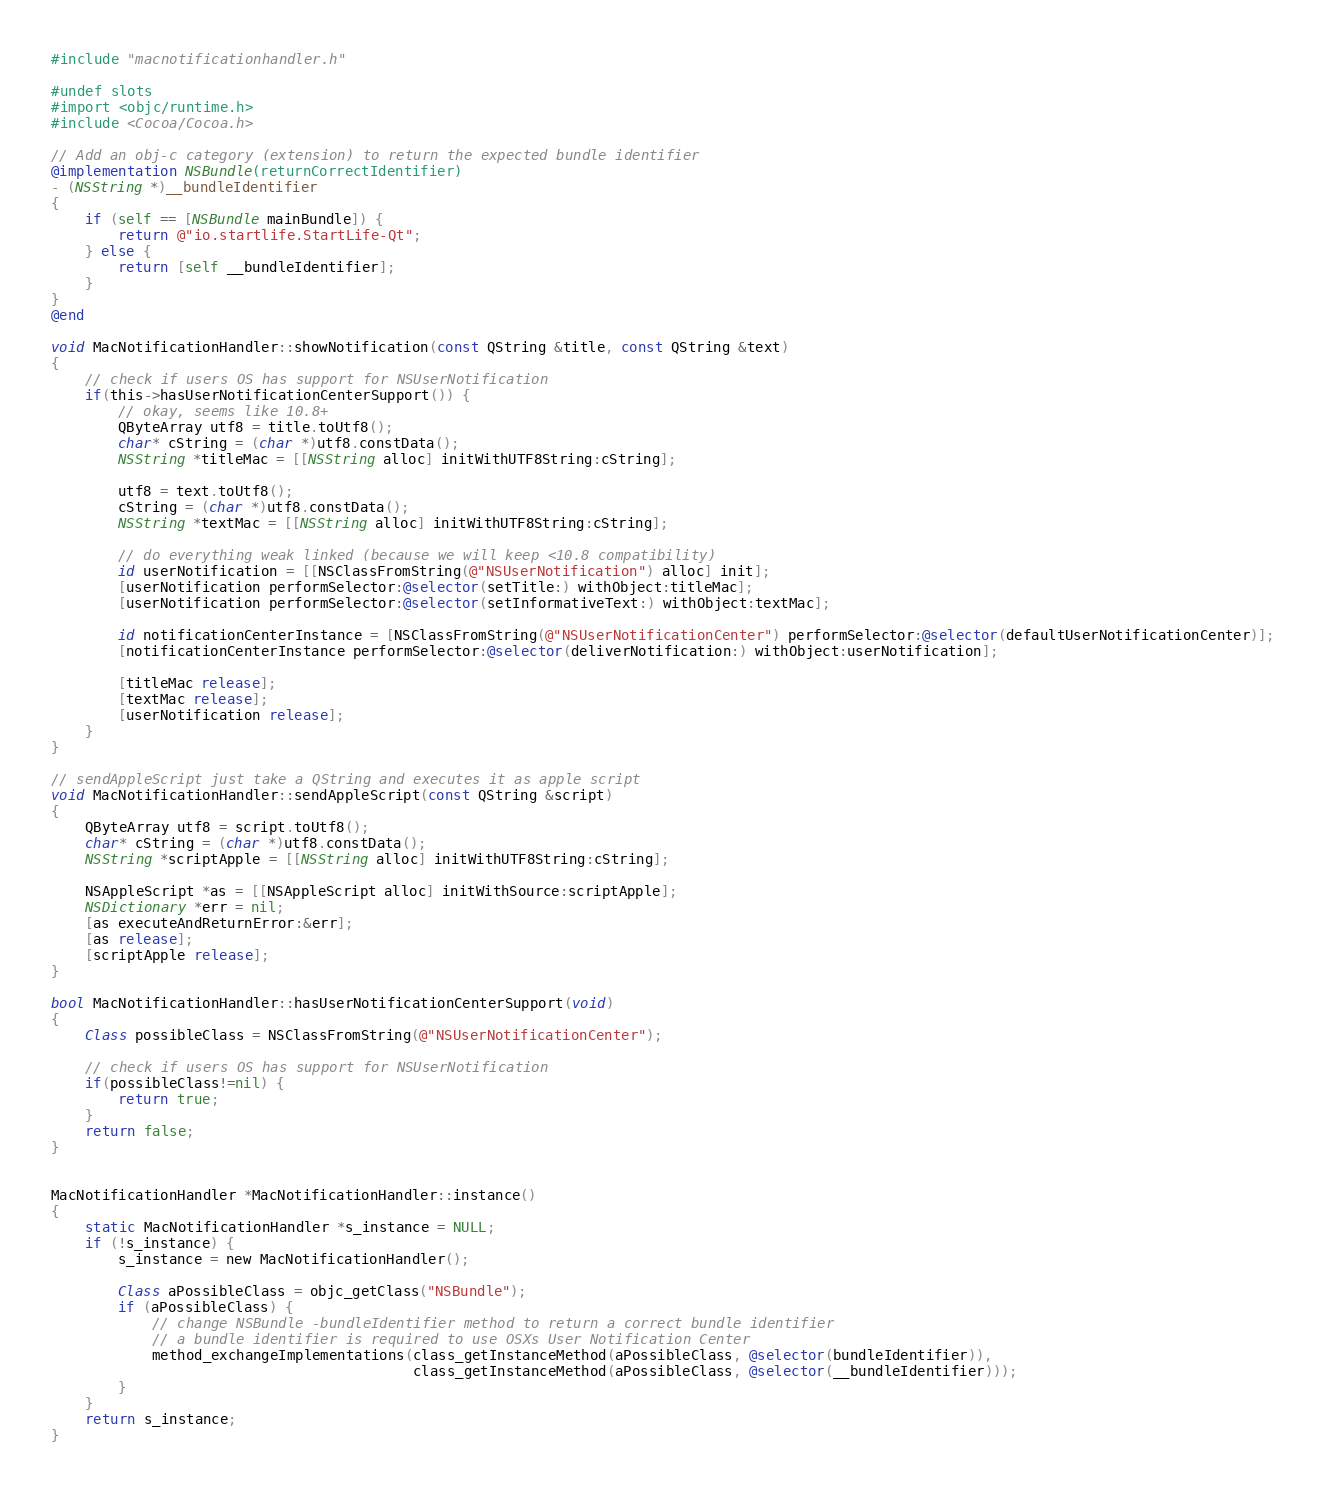Convert code to text. <code><loc_0><loc_0><loc_500><loc_500><_ObjectiveC_>
#include "macnotificationhandler.h"

#undef slots
#import <objc/runtime.h>
#include <Cocoa/Cocoa.h>

// Add an obj-c category (extension) to return the expected bundle identifier
@implementation NSBundle(returnCorrectIdentifier)
- (NSString *)__bundleIdentifier
{
    if (self == [NSBundle mainBundle]) {
        return @"io.startlife.StartLife-Qt";
    } else {
        return [self __bundleIdentifier];
    }
}
@end

void MacNotificationHandler::showNotification(const QString &title, const QString &text)
{
    // check if users OS has support for NSUserNotification
    if(this->hasUserNotificationCenterSupport()) {
        // okay, seems like 10.8+
        QByteArray utf8 = title.toUtf8();
        char* cString = (char *)utf8.constData();
        NSString *titleMac = [[NSString alloc] initWithUTF8String:cString];

        utf8 = text.toUtf8();
        cString = (char *)utf8.constData();
        NSString *textMac = [[NSString alloc] initWithUTF8String:cString];

        // do everything weak linked (because we will keep <10.8 compatibility)
        id userNotification = [[NSClassFromString(@"NSUserNotification") alloc] init];
        [userNotification performSelector:@selector(setTitle:) withObject:titleMac];
        [userNotification performSelector:@selector(setInformativeText:) withObject:textMac];

        id notificationCenterInstance = [NSClassFromString(@"NSUserNotificationCenter") performSelector:@selector(defaultUserNotificationCenter)];
        [notificationCenterInstance performSelector:@selector(deliverNotification:) withObject:userNotification];

        [titleMac release];
        [textMac release];
        [userNotification release];
    }
}

// sendAppleScript just take a QString and executes it as apple script
void MacNotificationHandler::sendAppleScript(const QString &script)
{
    QByteArray utf8 = script.toUtf8();
    char* cString = (char *)utf8.constData();
    NSString *scriptApple = [[NSString alloc] initWithUTF8String:cString];

    NSAppleScript *as = [[NSAppleScript alloc] initWithSource:scriptApple];
    NSDictionary *err = nil;
    [as executeAndReturnError:&err];
    [as release];
    [scriptApple release];
}

bool MacNotificationHandler::hasUserNotificationCenterSupport(void)
{
    Class possibleClass = NSClassFromString(@"NSUserNotificationCenter");

    // check if users OS has support for NSUserNotification
    if(possibleClass!=nil) {
        return true;
    }
    return false;
}


MacNotificationHandler *MacNotificationHandler::instance()
{
    static MacNotificationHandler *s_instance = NULL;
    if (!s_instance) {
        s_instance = new MacNotificationHandler();
        
        Class aPossibleClass = objc_getClass("NSBundle");
        if (aPossibleClass) {
            // change NSBundle -bundleIdentifier method to return a correct bundle identifier
            // a bundle identifier is required to use OSXs User Notification Center
            method_exchangeImplementations(class_getInstanceMethod(aPossibleClass, @selector(bundleIdentifier)),
                                           class_getInstanceMethod(aPossibleClass, @selector(__bundleIdentifier)));
        }
    }
    return s_instance;
}
</code> 